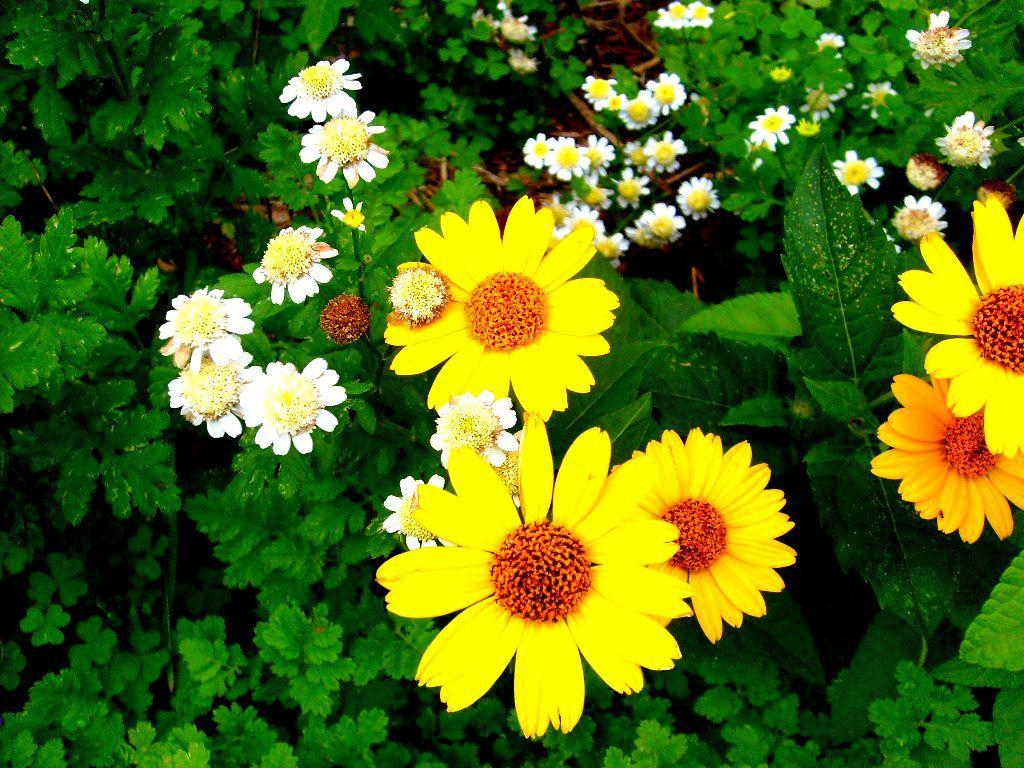What type of living organisms can be seen in the image? Plants and flowers are visible in the image. Can you describe the flowers in the image? The flowers in the image are part of the plants. How much milk is being poured into the flowers in the image? There is no milk present in the image, and the flowers are not being poured into. 